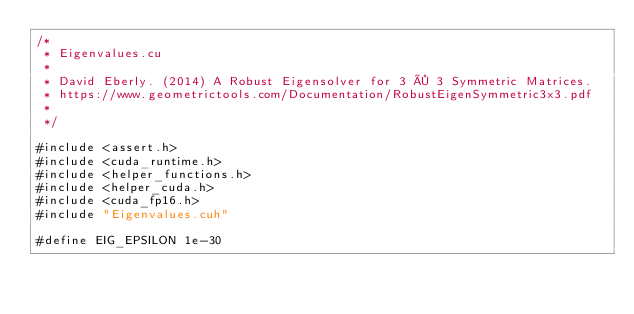Convert code to text. <code><loc_0><loc_0><loc_500><loc_500><_Cuda_>/*
 * Eigenvalues.cu
 *
 * David Eberly. (2014) A Robust Eigensolver for 3 × 3 Symmetric Matrices.
 * https://www.geometrictools.com/Documentation/RobustEigenSymmetric3x3.pdf
 *
 */

#include <assert.h>
#include <cuda_runtime.h>
#include <helper_functions.h>
#include <helper_cuda.h>
#include <cuda_fp16.h>
#include "Eigenvalues.cuh"

#define EIG_EPSILON 1e-30
</code> 